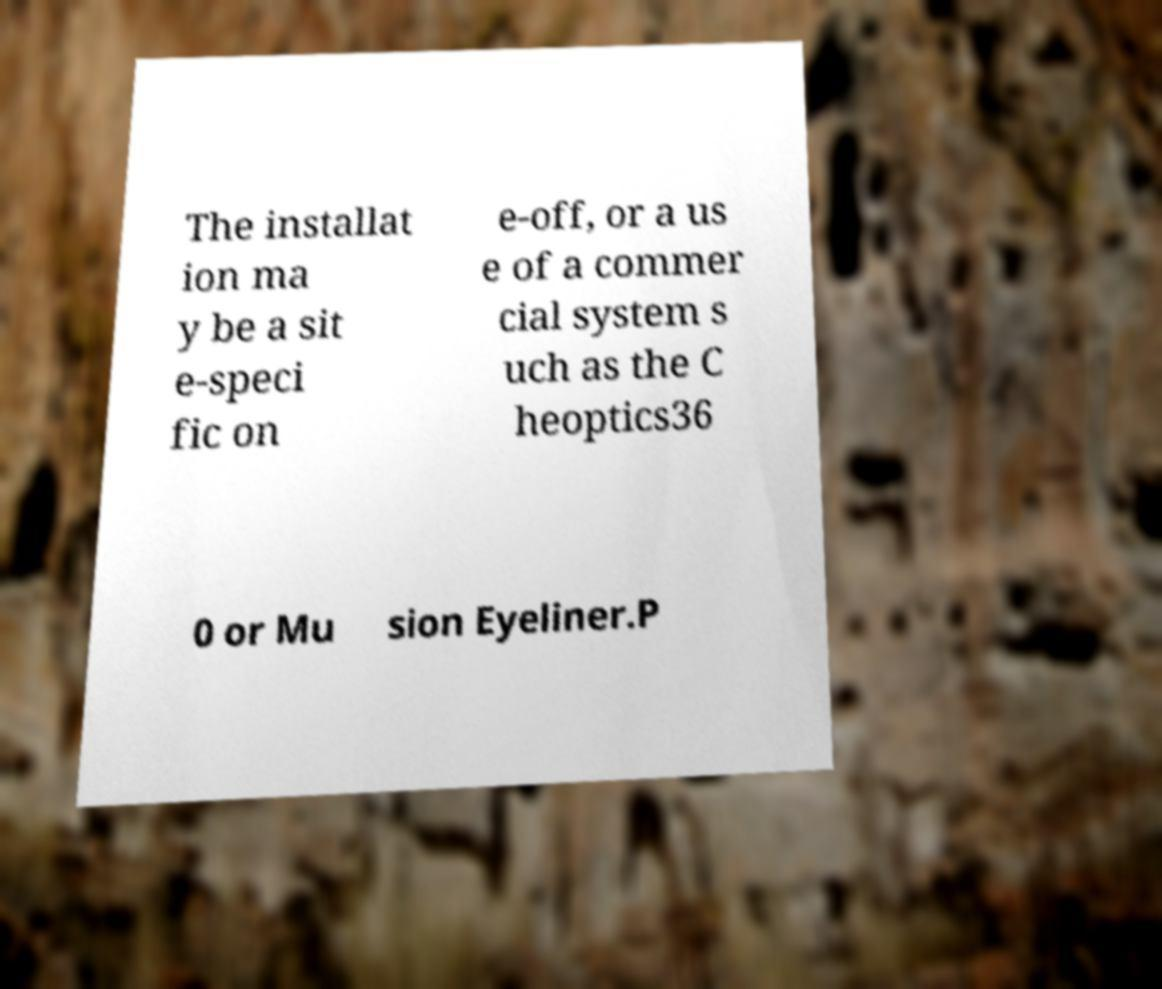Could you assist in decoding the text presented in this image and type it out clearly? The installat ion ma y be a sit e-speci fic on e-off, or a us e of a commer cial system s uch as the C heoptics36 0 or Mu sion Eyeliner.P 